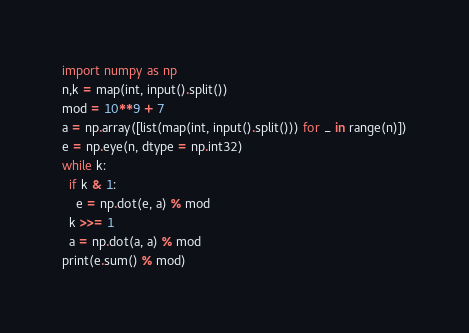Convert code to text. <code><loc_0><loc_0><loc_500><loc_500><_Python_>import numpy as np
n,k = map(int, input().split())
mod = 10**9 + 7
a = np.array([list(map(int, input().split())) for _ in range(n)])
e = np.eye(n, dtype = np.int32)
while k:
  if k & 1:
    e = np.dot(e, a) % mod
  k >>= 1
  a = np.dot(a, a) % mod
print(e.sum() % mod)</code> 